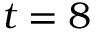<formula> <loc_0><loc_0><loc_500><loc_500>t = 8</formula> 